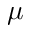<formula> <loc_0><loc_0><loc_500><loc_500>\mu</formula> 